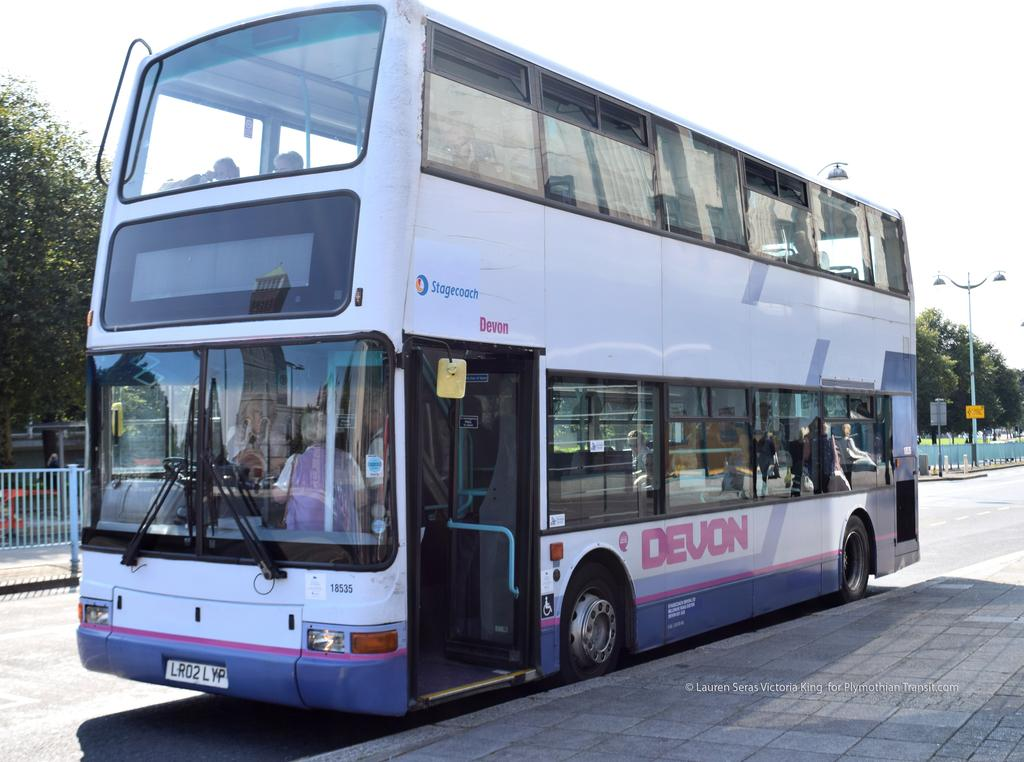<image>
Summarize the visual content of the image. A bus with a Devon logo on the side is on the street. 